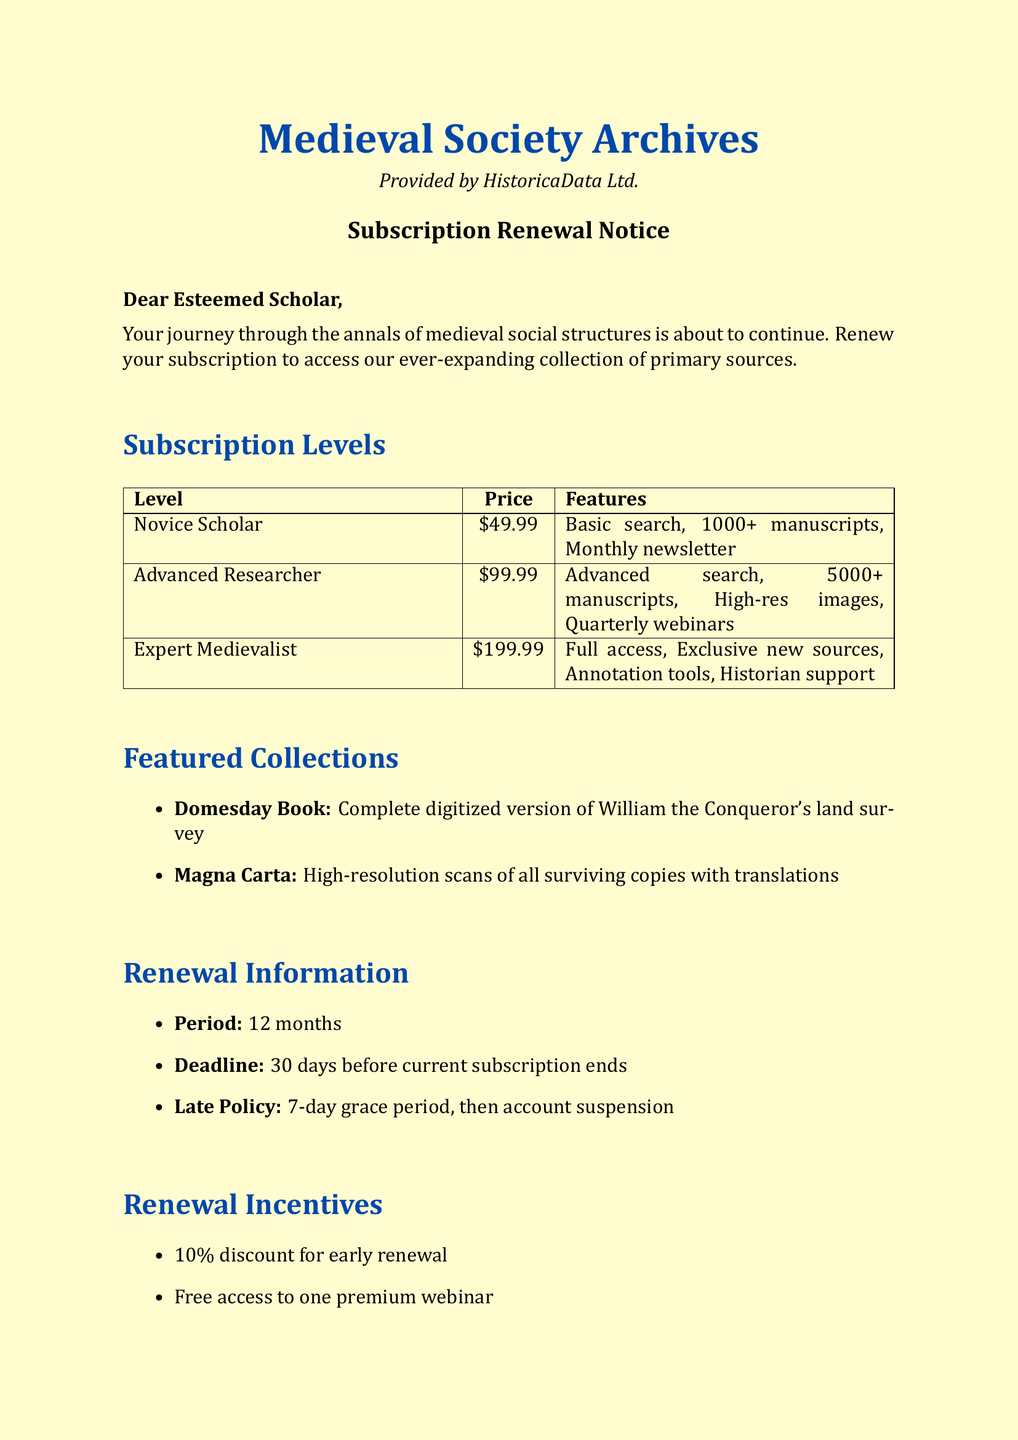what is the price of the Advanced Researcher subscription? The price of the Advanced Researcher subscription is listed in the subscription levels section of the document.
Answer: $99.99 how many digitized manuscripts can a Novice Scholar access? The document specifies the number of digitized manuscripts available to each subscription level. A Novice Scholar can access 1000+.
Answer: 1000+ what is the renewal deadline? The renewal deadline is specified within the renewal information section of the document, indicating when a renewal must occur.
Answer: 30 days before current subscription ends which featured collection includes William the Conqueror's land survey? The document describes the featured collections, specifically naming one related to William the Conqueror.
Answer: Domesday Book how long is the subscription period? This information is provided in the renewal information section and tells how long the subscription lasts.
Answer: 12 months what incentive do you receive for early renewal? The renewal incentives section mentions what benefits come with early renewal.
Answer: 10% discount which payment method is associated with the subscription? The document lists acceptable payment methods under a specific section.
Answer: Credit card what is the late renewal policy? The late renewal policy is stated explicitly in the renewal information section and indicates the consequences for missed deadlines.
Answer: 7-day grace period, then account suspension who can you contact for support? The document provides contact information for customer support at the end of the notice.
Answer: support@medievalsocietyarchives.com 